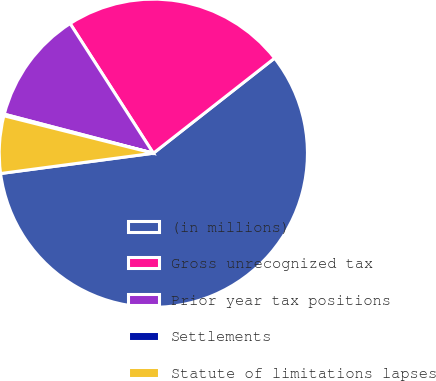<chart> <loc_0><loc_0><loc_500><loc_500><pie_chart><fcel>(in millions)<fcel>Gross unrecognized tax<fcel>Prior year tax positions<fcel>Settlements<fcel>Statute of limitations lapses<nl><fcel>58.49%<fcel>23.5%<fcel>11.84%<fcel>0.17%<fcel>6.01%<nl></chart> 